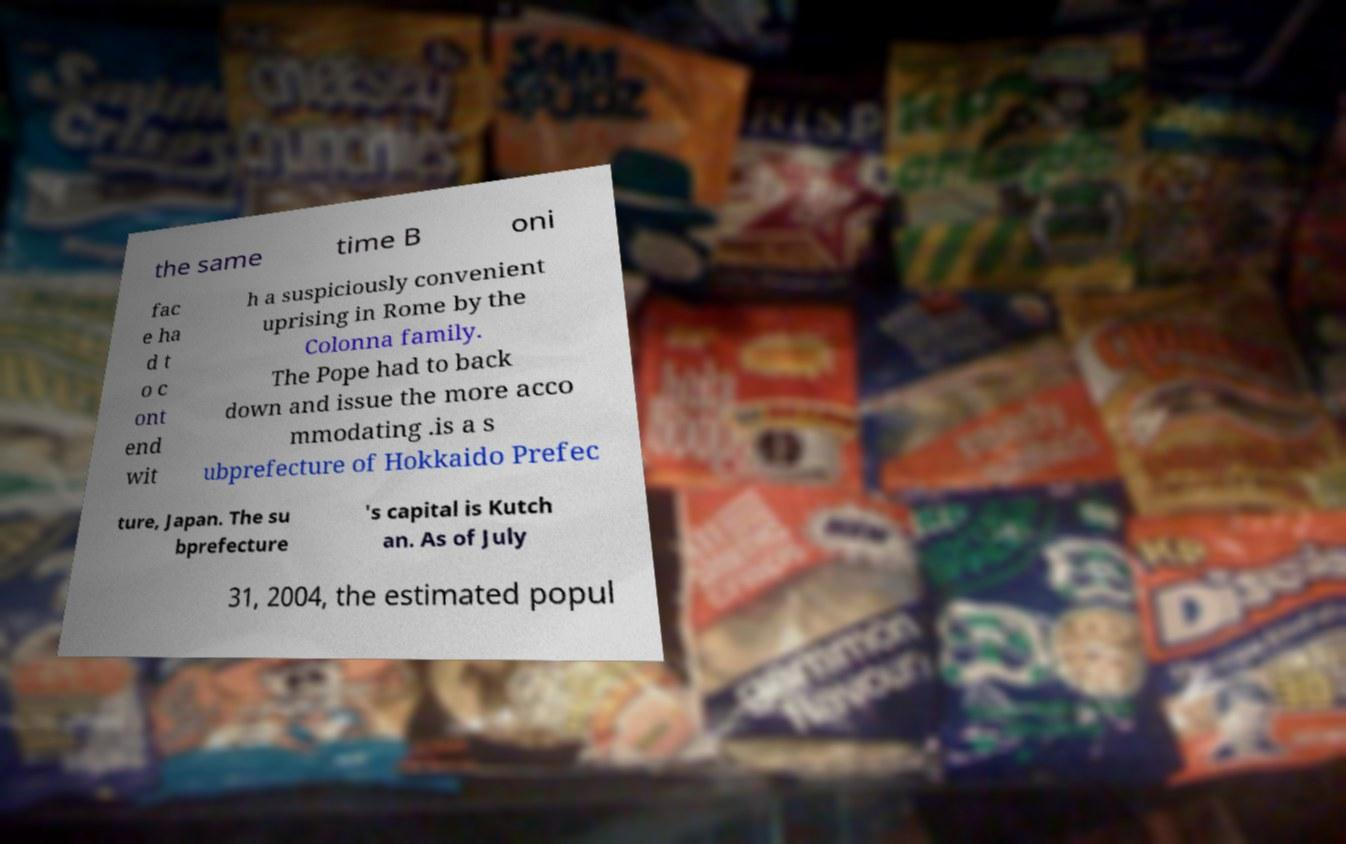Please read and relay the text visible in this image. What does it say? the same time B oni fac e ha d t o c ont end wit h a suspiciously convenient uprising in Rome by the Colonna family. The Pope had to back down and issue the more acco mmodating .is a s ubprefecture of Hokkaido Prefec ture, Japan. The su bprefecture 's capital is Kutch an. As of July 31, 2004, the estimated popul 